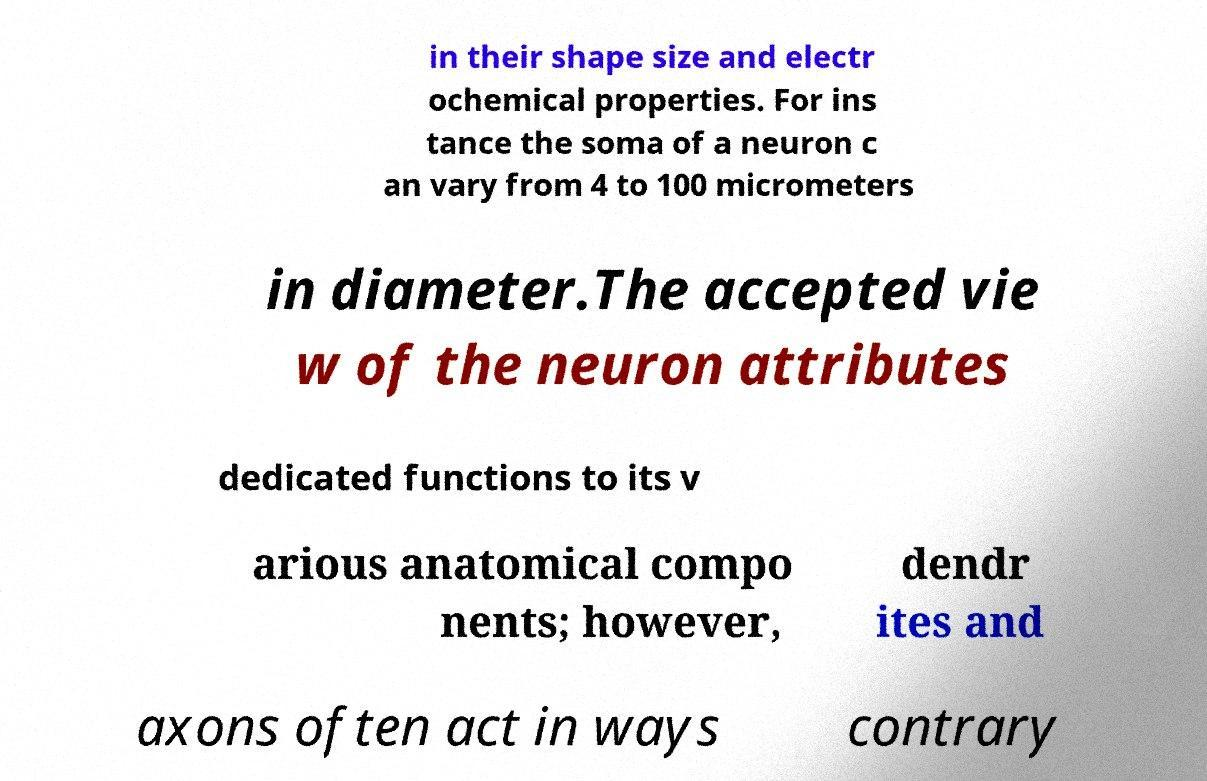I need the written content from this picture converted into text. Can you do that? in their shape size and electr ochemical properties. For ins tance the soma of a neuron c an vary from 4 to 100 micrometers in diameter.The accepted vie w of the neuron attributes dedicated functions to its v arious anatomical compo nents; however, dendr ites and axons often act in ways contrary 